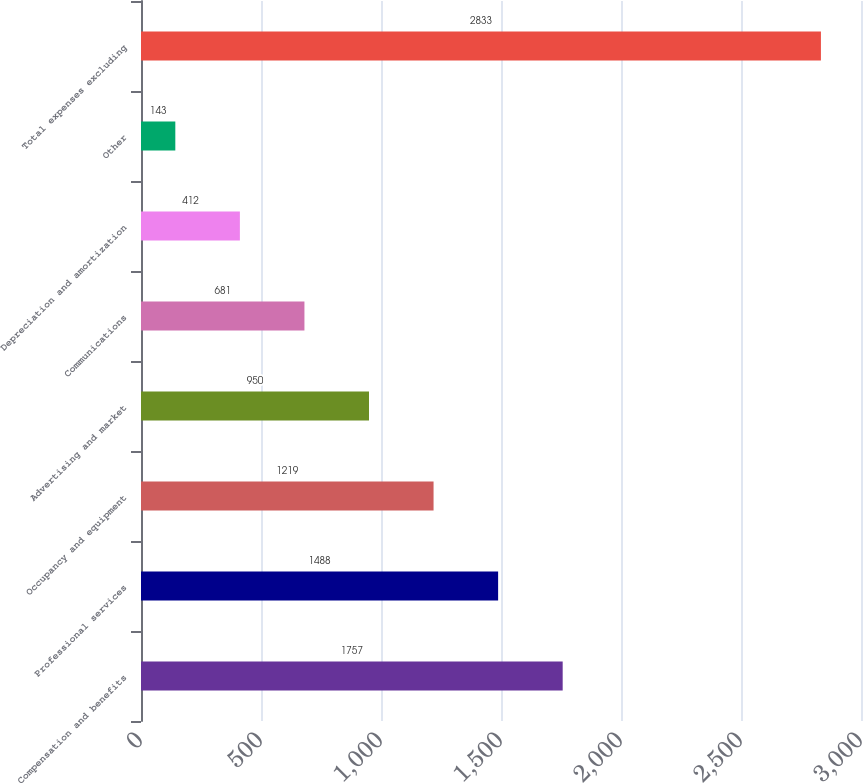Convert chart to OTSL. <chart><loc_0><loc_0><loc_500><loc_500><bar_chart><fcel>Compensation and benefits<fcel>Professional services<fcel>Occupancy and equipment<fcel>Advertising and market<fcel>Communications<fcel>Depreciation and amortization<fcel>Other<fcel>Total expenses excluding<nl><fcel>1757<fcel>1488<fcel>1219<fcel>950<fcel>681<fcel>412<fcel>143<fcel>2833<nl></chart> 